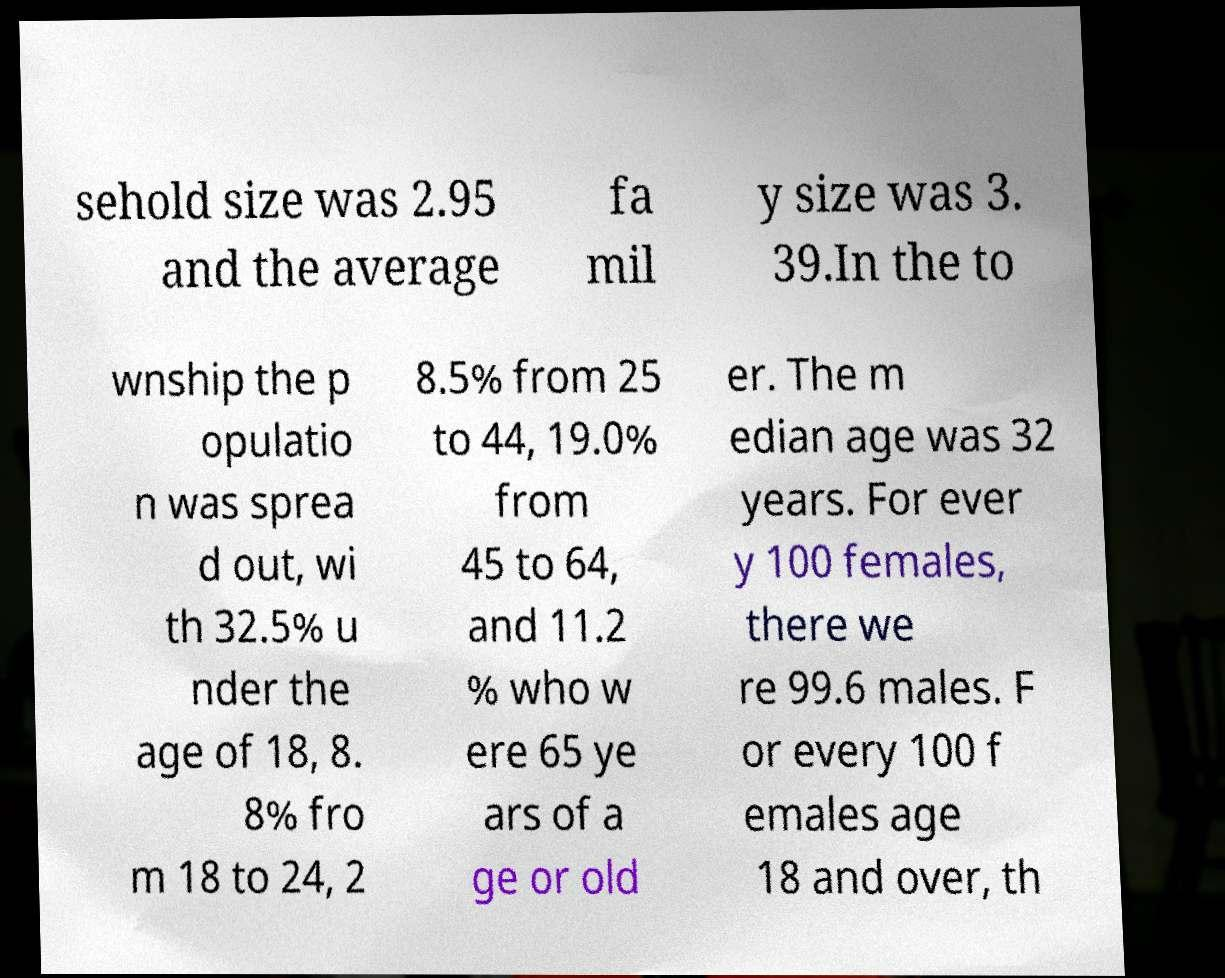Can you accurately transcribe the text from the provided image for me? sehold size was 2.95 and the average fa mil y size was 3. 39.In the to wnship the p opulatio n was sprea d out, wi th 32.5% u nder the age of 18, 8. 8% fro m 18 to 24, 2 8.5% from 25 to 44, 19.0% from 45 to 64, and 11.2 % who w ere 65 ye ars of a ge or old er. The m edian age was 32 years. For ever y 100 females, there we re 99.6 males. F or every 100 f emales age 18 and over, th 